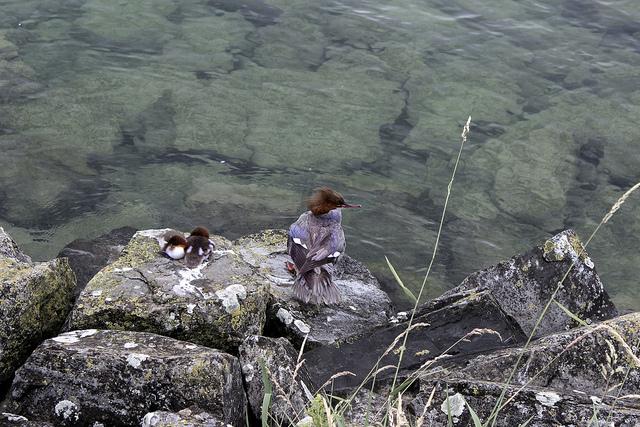Is this bird a nurturing animal?
Answer briefly. Yes. Do the baby birds belong to the adult bird?
Quick response, please. Yes. Will the birds go into the water?
Answer briefly. Yes. 